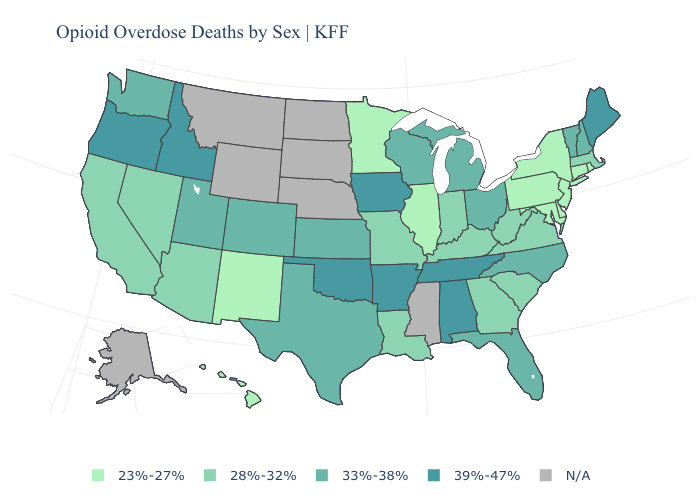Which states have the highest value in the USA?
Be succinct. Alabama, Arkansas, Idaho, Iowa, Maine, Oklahoma, Oregon, Tennessee. What is the value of Oregon?
Short answer required. 39%-47%. What is the value of Iowa?
Quick response, please. 39%-47%. Does Oklahoma have the highest value in the USA?
Quick response, please. Yes. Is the legend a continuous bar?
Answer briefly. No. How many symbols are there in the legend?
Short answer required. 5. Among the states that border Nevada , which have the highest value?
Short answer required. Idaho, Oregon. What is the value of New York?
Write a very short answer. 23%-27%. Name the states that have a value in the range 33%-38%?
Quick response, please. Colorado, Florida, Kansas, Michigan, New Hampshire, North Carolina, Ohio, Texas, Utah, Vermont, Washington, Wisconsin. Does Wisconsin have the highest value in the MidWest?
Keep it brief. No. What is the highest value in states that border Colorado?
Give a very brief answer. 39%-47%. Among the states that border West Virginia , does Ohio have the lowest value?
Short answer required. No. What is the lowest value in states that border Colorado?
Answer briefly. 23%-27%. Does the first symbol in the legend represent the smallest category?
Write a very short answer. Yes. Among the states that border Maryland , does Virginia have the highest value?
Short answer required. Yes. 